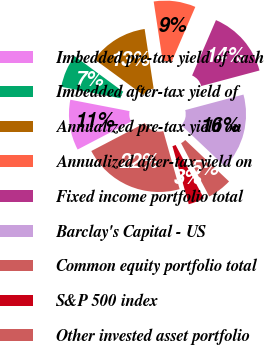Convert chart. <chart><loc_0><loc_0><loc_500><loc_500><pie_chart><fcel>Imbedded pre-tax yield of cash<fcel>Imbedded after-tax yield of<fcel>Annualized pre-tax yield on<fcel>Annualized after-tax yield on<fcel>Fixed income portfolio total<fcel>Barclay's Capital - US<fcel>Common equity portfolio total<fcel>S&P 500 index<fcel>Other invested asset portfolio<nl><fcel>10.7%<fcel>7.04%<fcel>12.54%<fcel>8.87%<fcel>14.37%<fcel>16.2%<fcel>5.21%<fcel>3.38%<fcel>21.7%<nl></chart> 